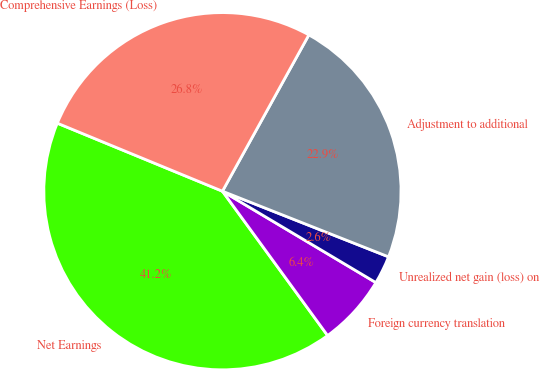Convert chart to OTSL. <chart><loc_0><loc_0><loc_500><loc_500><pie_chart><fcel>Net Earnings<fcel>Foreign currency translation<fcel>Unrealized net gain (loss) on<fcel>Adjustment to additional<fcel>Comprehensive Earnings (Loss)<nl><fcel>41.24%<fcel>6.43%<fcel>2.56%<fcel>22.95%<fcel>26.82%<nl></chart> 